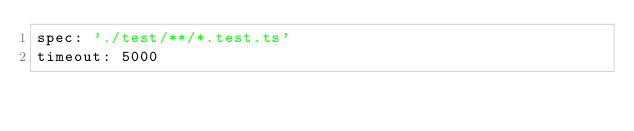<code> <loc_0><loc_0><loc_500><loc_500><_YAML_>spec: './test/**/*.test.ts'
timeout: 5000
</code> 